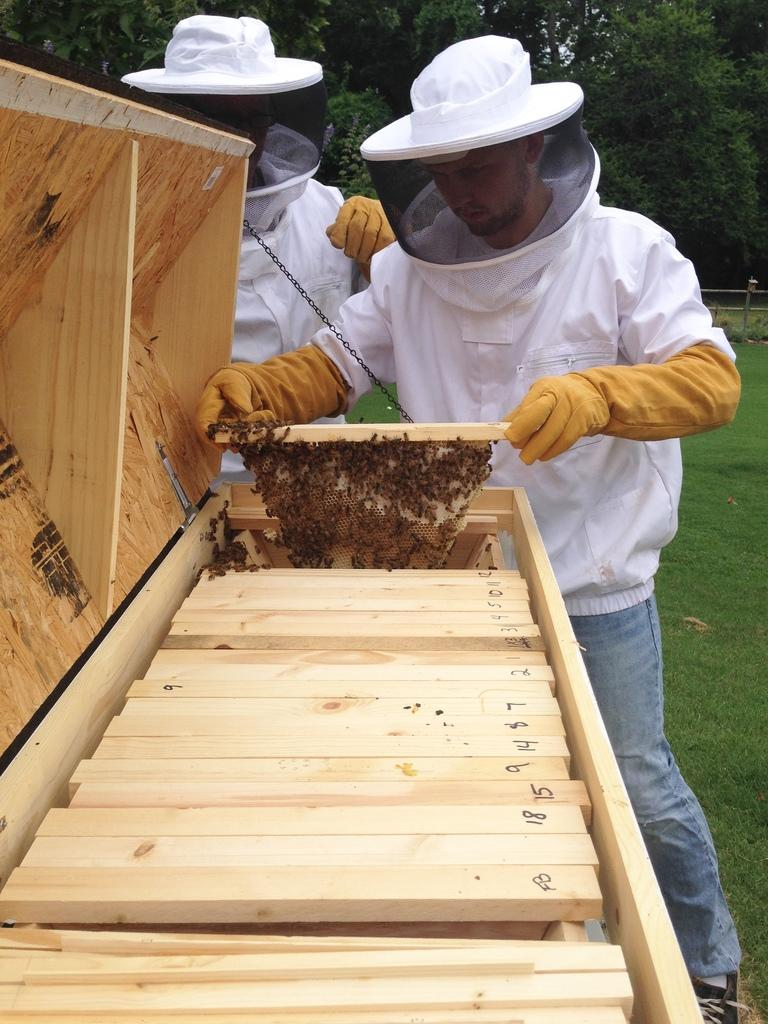How many persons are in the image? There are persons in the image. What type of objects can be seen in the image? There are wooden objects and other objects in the image. What can be seen in the background of the image? There are trees, a fence, sky, and other objects in the background of the image. Reasoning: Let'g: Let's think step by step in order to produce the conversation. We start by acknowledging the presence of persons in the image. Then, we describe the types of objects that can be seen, including wooden objects and other objects. Finally, we provide details about the background of the image, which includes trees, a fence, sky, and other objects. Absurd Question/Answer: How many ducks are sitting on the fence in the image? There are no ducks present in the image. What type of alarm is going off in the background of the image? There is no alarm present in the image. 